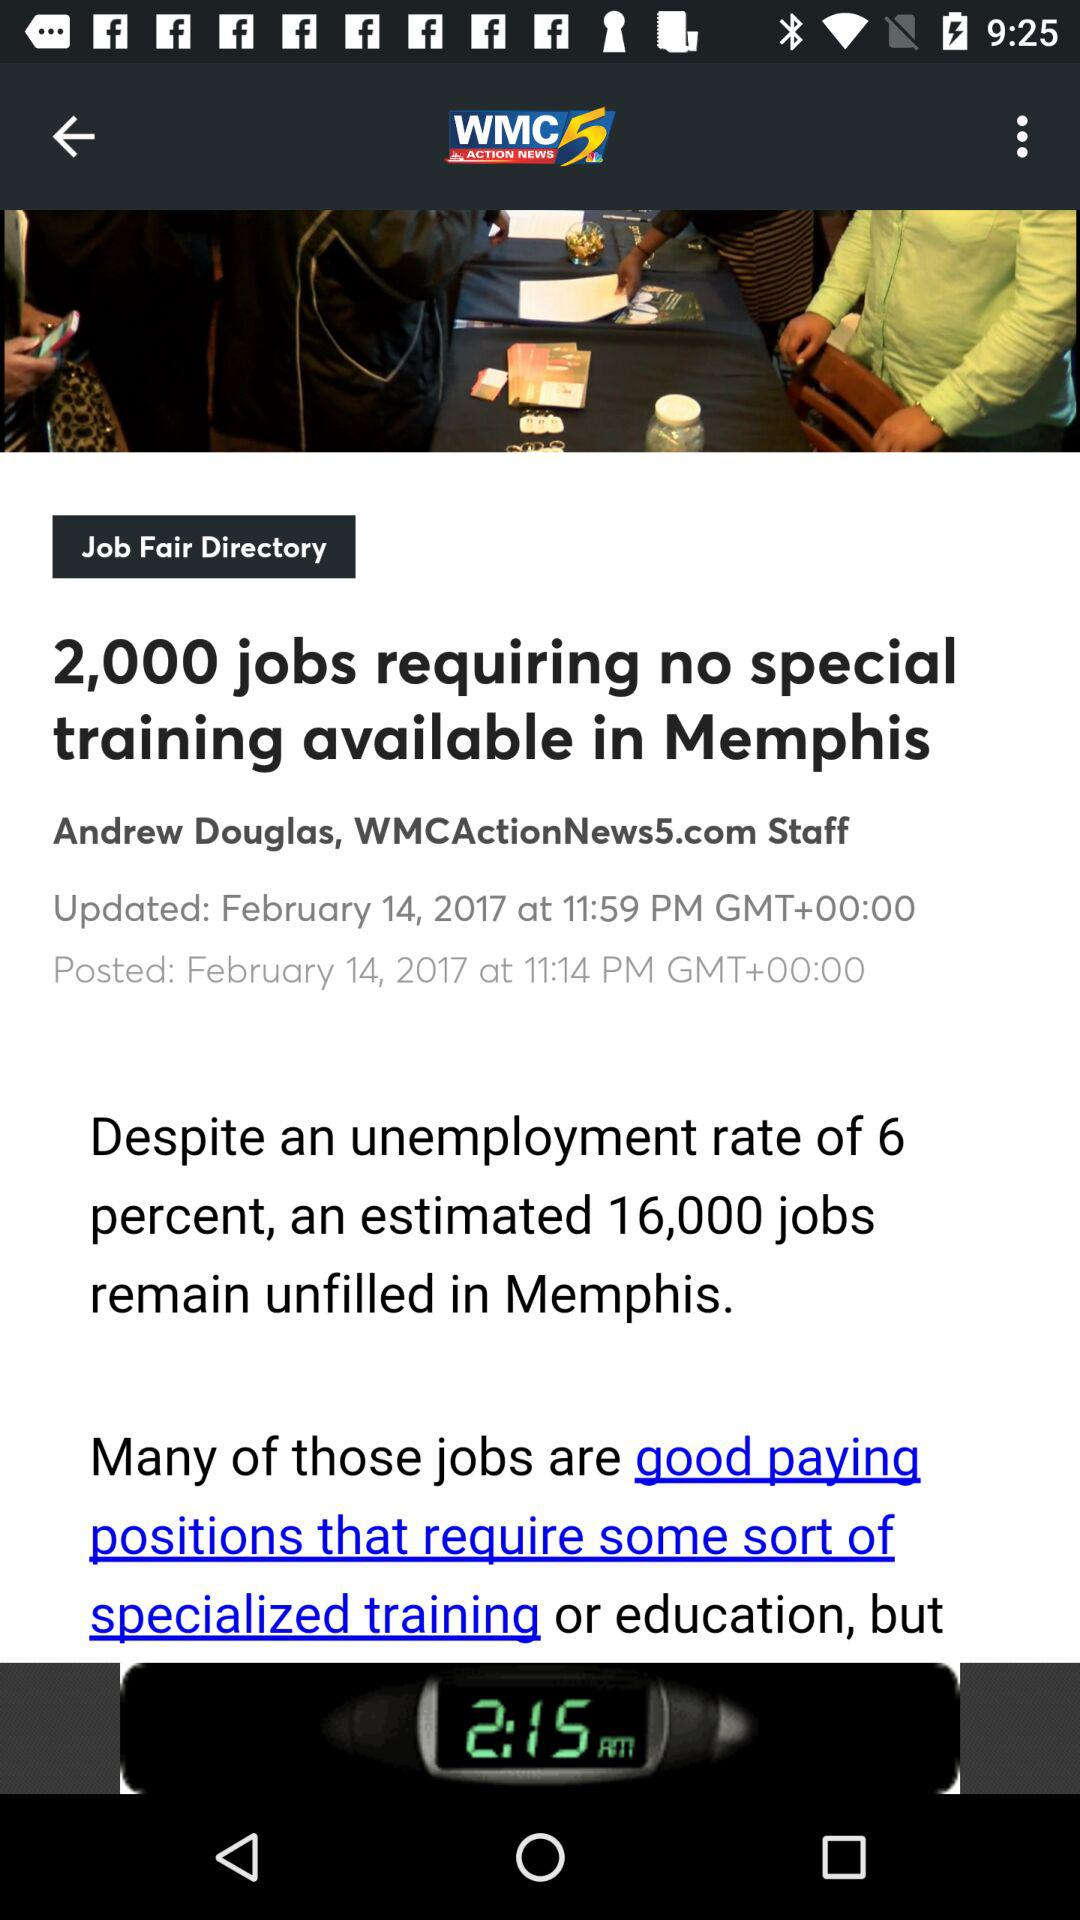What is the updated date of the article? The updated date of the article is February 14, 2017. 